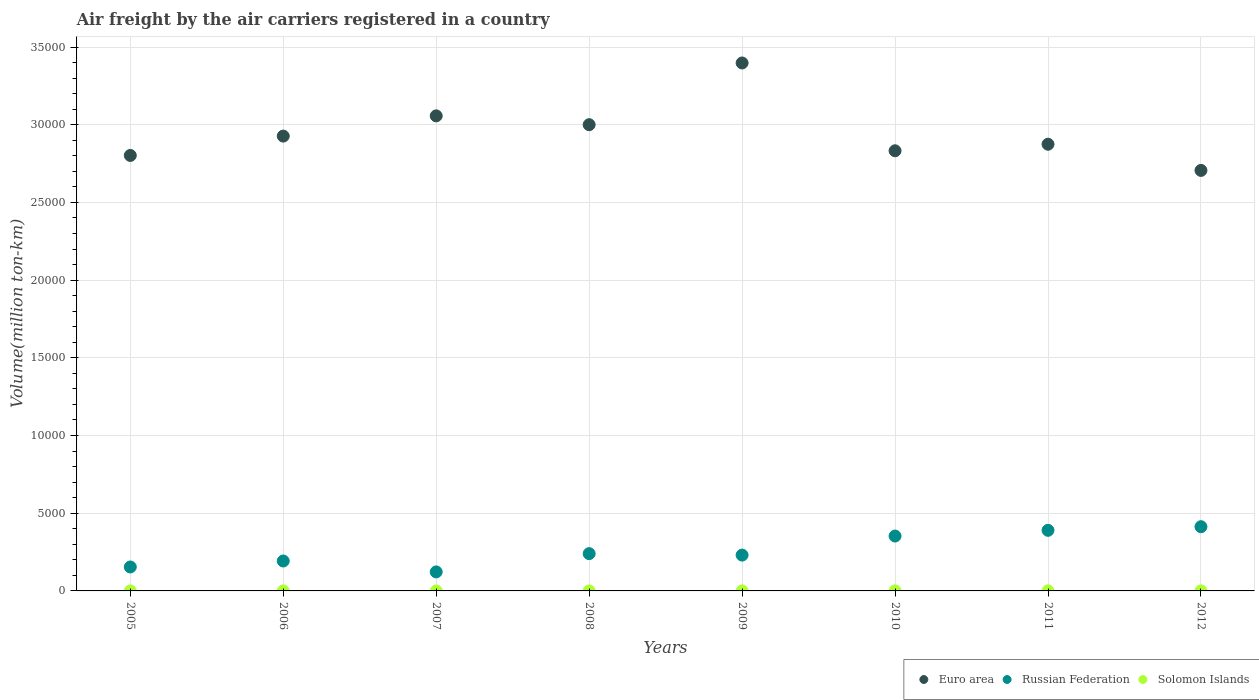Is the number of dotlines equal to the number of legend labels?
Provide a short and direct response. Yes. What is the volume of the air carriers in Solomon Islands in 2006?
Offer a terse response. 0.83. Across all years, what is the maximum volume of the air carriers in Solomon Islands?
Provide a short and direct response. 3.02. Across all years, what is the minimum volume of the air carriers in Solomon Islands?
Give a very brief answer. 0.72. In which year was the volume of the air carriers in Euro area maximum?
Provide a short and direct response. 2009. What is the total volume of the air carriers in Russian Federation in the graph?
Give a very brief answer. 2.10e+04. What is the difference between the volume of the air carriers in Euro area in 2005 and that in 2007?
Your answer should be compact. -2547.47. What is the difference between the volume of the air carriers in Solomon Islands in 2011 and the volume of the air carriers in Russian Federation in 2007?
Offer a terse response. -1221.49. What is the average volume of the air carriers in Euro area per year?
Your answer should be compact. 2.95e+04. In the year 2006, what is the difference between the volume of the air carriers in Russian Federation and volume of the air carriers in Euro area?
Keep it short and to the point. -2.73e+04. In how many years, is the volume of the air carriers in Russian Federation greater than 28000 million ton-km?
Ensure brevity in your answer.  0. What is the ratio of the volume of the air carriers in Russian Federation in 2010 to that in 2011?
Offer a very short reply. 0.91. Is the volume of the air carriers in Euro area in 2007 less than that in 2012?
Keep it short and to the point. No. What is the difference between the highest and the second highest volume of the air carriers in Euro area?
Your answer should be very brief. 3403.68. What is the difference between the highest and the lowest volume of the air carriers in Russian Federation?
Make the answer very short. 2907.83. In how many years, is the volume of the air carriers in Solomon Islands greater than the average volume of the air carriers in Solomon Islands taken over all years?
Provide a short and direct response. 3. Is the sum of the volume of the air carriers in Solomon Islands in 2006 and 2012 greater than the maximum volume of the air carriers in Euro area across all years?
Give a very brief answer. No. How many dotlines are there?
Ensure brevity in your answer.  3. How many years are there in the graph?
Offer a very short reply. 8. What is the difference between two consecutive major ticks on the Y-axis?
Keep it short and to the point. 5000. Are the values on the major ticks of Y-axis written in scientific E-notation?
Keep it short and to the point. No. Does the graph contain any zero values?
Your answer should be very brief. No. Where does the legend appear in the graph?
Make the answer very short. Bottom right. How are the legend labels stacked?
Your response must be concise. Horizontal. What is the title of the graph?
Your answer should be compact. Air freight by the air carriers registered in a country. What is the label or title of the X-axis?
Make the answer very short. Years. What is the label or title of the Y-axis?
Make the answer very short. Volume(million ton-km). What is the Volume(million ton-km) of Euro area in 2005?
Your answer should be very brief. 2.80e+04. What is the Volume(million ton-km) in Russian Federation in 2005?
Your answer should be very brief. 1541.22. What is the Volume(million ton-km) of Solomon Islands in 2005?
Give a very brief answer. 0.8. What is the Volume(million ton-km) in Euro area in 2006?
Provide a short and direct response. 2.93e+04. What is the Volume(million ton-km) of Russian Federation in 2006?
Provide a succinct answer. 1926.3. What is the Volume(million ton-km) in Solomon Islands in 2006?
Give a very brief answer. 0.83. What is the Volume(million ton-km) in Euro area in 2007?
Make the answer very short. 3.06e+04. What is the Volume(million ton-km) of Russian Federation in 2007?
Offer a very short reply. 1224.31. What is the Volume(million ton-km) in Solomon Islands in 2007?
Offer a terse response. 0.88. What is the Volume(million ton-km) of Euro area in 2008?
Offer a very short reply. 3.00e+04. What is the Volume(million ton-km) in Russian Federation in 2008?
Provide a short and direct response. 2399.59. What is the Volume(million ton-km) in Solomon Islands in 2008?
Keep it short and to the point. 0.83. What is the Volume(million ton-km) in Euro area in 2009?
Keep it short and to the point. 3.40e+04. What is the Volume(million ton-km) in Russian Federation in 2009?
Your answer should be very brief. 2305.55. What is the Volume(million ton-km) of Solomon Islands in 2009?
Ensure brevity in your answer.  0.72. What is the Volume(million ton-km) of Euro area in 2010?
Keep it short and to the point. 2.83e+04. What is the Volume(million ton-km) in Russian Federation in 2010?
Make the answer very short. 3531.58. What is the Volume(million ton-km) in Solomon Islands in 2010?
Your answer should be very brief. 2.55. What is the Volume(million ton-km) in Euro area in 2011?
Ensure brevity in your answer.  2.87e+04. What is the Volume(million ton-km) in Russian Federation in 2011?
Give a very brief answer. 3900.12. What is the Volume(million ton-km) in Solomon Islands in 2011?
Give a very brief answer. 2.82. What is the Volume(million ton-km) in Euro area in 2012?
Provide a short and direct response. 2.71e+04. What is the Volume(million ton-km) in Russian Federation in 2012?
Offer a terse response. 4132.14. What is the Volume(million ton-km) in Solomon Islands in 2012?
Keep it short and to the point. 3.02. Across all years, what is the maximum Volume(million ton-km) of Euro area?
Ensure brevity in your answer.  3.40e+04. Across all years, what is the maximum Volume(million ton-km) of Russian Federation?
Offer a terse response. 4132.14. Across all years, what is the maximum Volume(million ton-km) in Solomon Islands?
Offer a terse response. 3.02. Across all years, what is the minimum Volume(million ton-km) of Euro area?
Make the answer very short. 2.71e+04. Across all years, what is the minimum Volume(million ton-km) in Russian Federation?
Offer a very short reply. 1224.31. Across all years, what is the minimum Volume(million ton-km) in Solomon Islands?
Offer a very short reply. 0.72. What is the total Volume(million ton-km) in Euro area in the graph?
Provide a short and direct response. 2.36e+05. What is the total Volume(million ton-km) in Russian Federation in the graph?
Offer a terse response. 2.10e+04. What is the total Volume(million ton-km) in Solomon Islands in the graph?
Offer a very short reply. 12.44. What is the difference between the Volume(million ton-km) in Euro area in 2005 and that in 2006?
Offer a terse response. -1245.56. What is the difference between the Volume(million ton-km) of Russian Federation in 2005 and that in 2006?
Make the answer very short. -385.08. What is the difference between the Volume(million ton-km) in Solomon Islands in 2005 and that in 2006?
Give a very brief answer. -0.03. What is the difference between the Volume(million ton-km) of Euro area in 2005 and that in 2007?
Provide a succinct answer. -2547.47. What is the difference between the Volume(million ton-km) of Russian Federation in 2005 and that in 2007?
Your response must be concise. 316.91. What is the difference between the Volume(million ton-km) in Solomon Islands in 2005 and that in 2007?
Offer a terse response. -0.08. What is the difference between the Volume(million ton-km) in Euro area in 2005 and that in 2008?
Your response must be concise. -1979.42. What is the difference between the Volume(million ton-km) in Russian Federation in 2005 and that in 2008?
Your response must be concise. -858.37. What is the difference between the Volume(million ton-km) of Solomon Islands in 2005 and that in 2008?
Your answer should be compact. -0.03. What is the difference between the Volume(million ton-km) in Euro area in 2005 and that in 2009?
Give a very brief answer. -5951.15. What is the difference between the Volume(million ton-km) of Russian Federation in 2005 and that in 2009?
Provide a succinct answer. -764.33. What is the difference between the Volume(million ton-km) of Solomon Islands in 2005 and that in 2009?
Keep it short and to the point. 0.07. What is the difference between the Volume(million ton-km) of Euro area in 2005 and that in 2010?
Your answer should be compact. -300.19. What is the difference between the Volume(million ton-km) in Russian Federation in 2005 and that in 2010?
Ensure brevity in your answer.  -1990.36. What is the difference between the Volume(million ton-km) in Solomon Islands in 2005 and that in 2010?
Provide a short and direct response. -1.75. What is the difference between the Volume(million ton-km) of Euro area in 2005 and that in 2011?
Provide a short and direct response. -721.69. What is the difference between the Volume(million ton-km) of Russian Federation in 2005 and that in 2011?
Offer a terse response. -2358.9. What is the difference between the Volume(million ton-km) in Solomon Islands in 2005 and that in 2011?
Make the answer very short. -2.02. What is the difference between the Volume(million ton-km) of Euro area in 2005 and that in 2012?
Give a very brief answer. 962.52. What is the difference between the Volume(million ton-km) in Russian Federation in 2005 and that in 2012?
Offer a terse response. -2590.93. What is the difference between the Volume(million ton-km) in Solomon Islands in 2005 and that in 2012?
Your answer should be very brief. -2.23. What is the difference between the Volume(million ton-km) in Euro area in 2006 and that in 2007?
Offer a terse response. -1301.91. What is the difference between the Volume(million ton-km) in Russian Federation in 2006 and that in 2007?
Provide a short and direct response. 701.98. What is the difference between the Volume(million ton-km) of Solomon Islands in 2006 and that in 2007?
Provide a succinct answer. -0.05. What is the difference between the Volume(million ton-km) in Euro area in 2006 and that in 2008?
Offer a terse response. -733.86. What is the difference between the Volume(million ton-km) of Russian Federation in 2006 and that in 2008?
Make the answer very short. -473.3. What is the difference between the Volume(million ton-km) in Solomon Islands in 2006 and that in 2008?
Make the answer very short. -0. What is the difference between the Volume(million ton-km) in Euro area in 2006 and that in 2009?
Give a very brief answer. -4705.59. What is the difference between the Volume(million ton-km) of Russian Federation in 2006 and that in 2009?
Ensure brevity in your answer.  -379.25. What is the difference between the Volume(million ton-km) of Solomon Islands in 2006 and that in 2009?
Make the answer very short. 0.1. What is the difference between the Volume(million ton-km) of Euro area in 2006 and that in 2010?
Ensure brevity in your answer.  945.37. What is the difference between the Volume(million ton-km) in Russian Federation in 2006 and that in 2010?
Offer a very short reply. -1605.29. What is the difference between the Volume(million ton-km) of Solomon Islands in 2006 and that in 2010?
Ensure brevity in your answer.  -1.72. What is the difference between the Volume(million ton-km) of Euro area in 2006 and that in 2011?
Your response must be concise. 523.87. What is the difference between the Volume(million ton-km) of Russian Federation in 2006 and that in 2011?
Provide a short and direct response. -1973.83. What is the difference between the Volume(million ton-km) of Solomon Islands in 2006 and that in 2011?
Provide a short and direct response. -1.99. What is the difference between the Volume(million ton-km) in Euro area in 2006 and that in 2012?
Provide a succinct answer. 2208.08. What is the difference between the Volume(million ton-km) of Russian Federation in 2006 and that in 2012?
Make the answer very short. -2205.85. What is the difference between the Volume(million ton-km) of Solomon Islands in 2006 and that in 2012?
Your answer should be very brief. -2.2. What is the difference between the Volume(million ton-km) of Euro area in 2007 and that in 2008?
Your response must be concise. 568.05. What is the difference between the Volume(million ton-km) in Russian Federation in 2007 and that in 2008?
Provide a succinct answer. -1175.28. What is the difference between the Volume(million ton-km) in Solomon Islands in 2007 and that in 2008?
Your response must be concise. 0.04. What is the difference between the Volume(million ton-km) of Euro area in 2007 and that in 2009?
Provide a succinct answer. -3403.68. What is the difference between the Volume(million ton-km) in Russian Federation in 2007 and that in 2009?
Offer a very short reply. -1081.23. What is the difference between the Volume(million ton-km) in Solomon Islands in 2007 and that in 2009?
Offer a terse response. 0.15. What is the difference between the Volume(million ton-km) in Euro area in 2007 and that in 2010?
Ensure brevity in your answer.  2247.29. What is the difference between the Volume(million ton-km) in Russian Federation in 2007 and that in 2010?
Provide a succinct answer. -2307.27. What is the difference between the Volume(million ton-km) in Solomon Islands in 2007 and that in 2010?
Provide a short and direct response. -1.67. What is the difference between the Volume(million ton-km) of Euro area in 2007 and that in 2011?
Your response must be concise. 1825.79. What is the difference between the Volume(million ton-km) in Russian Federation in 2007 and that in 2011?
Provide a succinct answer. -2675.81. What is the difference between the Volume(million ton-km) of Solomon Islands in 2007 and that in 2011?
Provide a succinct answer. -1.94. What is the difference between the Volume(million ton-km) of Euro area in 2007 and that in 2012?
Provide a short and direct response. 3509.99. What is the difference between the Volume(million ton-km) of Russian Federation in 2007 and that in 2012?
Provide a succinct answer. -2907.83. What is the difference between the Volume(million ton-km) of Solomon Islands in 2007 and that in 2012?
Ensure brevity in your answer.  -2.15. What is the difference between the Volume(million ton-km) in Euro area in 2008 and that in 2009?
Ensure brevity in your answer.  -3971.73. What is the difference between the Volume(million ton-km) of Russian Federation in 2008 and that in 2009?
Your response must be concise. 94.05. What is the difference between the Volume(million ton-km) of Solomon Islands in 2008 and that in 2009?
Your answer should be very brief. 0.11. What is the difference between the Volume(million ton-km) in Euro area in 2008 and that in 2010?
Provide a succinct answer. 1679.23. What is the difference between the Volume(million ton-km) of Russian Federation in 2008 and that in 2010?
Give a very brief answer. -1131.99. What is the difference between the Volume(million ton-km) of Solomon Islands in 2008 and that in 2010?
Your response must be concise. -1.72. What is the difference between the Volume(million ton-km) in Euro area in 2008 and that in 2011?
Your answer should be compact. 1257.73. What is the difference between the Volume(million ton-km) in Russian Federation in 2008 and that in 2011?
Your answer should be very brief. -1500.53. What is the difference between the Volume(million ton-km) in Solomon Islands in 2008 and that in 2011?
Your answer should be very brief. -1.99. What is the difference between the Volume(million ton-km) of Euro area in 2008 and that in 2012?
Offer a very short reply. 2941.94. What is the difference between the Volume(million ton-km) of Russian Federation in 2008 and that in 2012?
Offer a very short reply. -1732.55. What is the difference between the Volume(million ton-km) in Solomon Islands in 2008 and that in 2012?
Offer a terse response. -2.19. What is the difference between the Volume(million ton-km) of Euro area in 2009 and that in 2010?
Make the answer very short. 5650.96. What is the difference between the Volume(million ton-km) of Russian Federation in 2009 and that in 2010?
Your answer should be very brief. -1226.04. What is the difference between the Volume(million ton-km) in Solomon Islands in 2009 and that in 2010?
Your response must be concise. -1.82. What is the difference between the Volume(million ton-km) in Euro area in 2009 and that in 2011?
Offer a very short reply. 5229.46. What is the difference between the Volume(million ton-km) of Russian Federation in 2009 and that in 2011?
Your answer should be very brief. -1594.57. What is the difference between the Volume(million ton-km) in Solomon Islands in 2009 and that in 2011?
Your answer should be compact. -2.1. What is the difference between the Volume(million ton-km) of Euro area in 2009 and that in 2012?
Make the answer very short. 6913.67. What is the difference between the Volume(million ton-km) in Russian Federation in 2009 and that in 2012?
Your response must be concise. -1826.6. What is the difference between the Volume(million ton-km) in Solomon Islands in 2009 and that in 2012?
Keep it short and to the point. -2.3. What is the difference between the Volume(million ton-km) in Euro area in 2010 and that in 2011?
Offer a very short reply. -421.5. What is the difference between the Volume(million ton-km) in Russian Federation in 2010 and that in 2011?
Your response must be concise. -368.54. What is the difference between the Volume(million ton-km) in Solomon Islands in 2010 and that in 2011?
Offer a very short reply. -0.27. What is the difference between the Volume(million ton-km) in Euro area in 2010 and that in 2012?
Offer a very short reply. 1262.71. What is the difference between the Volume(million ton-km) of Russian Federation in 2010 and that in 2012?
Provide a short and direct response. -600.56. What is the difference between the Volume(million ton-km) in Solomon Islands in 2010 and that in 2012?
Offer a very short reply. -0.48. What is the difference between the Volume(million ton-km) in Euro area in 2011 and that in 2012?
Provide a succinct answer. 1684.21. What is the difference between the Volume(million ton-km) in Russian Federation in 2011 and that in 2012?
Provide a succinct answer. -232.02. What is the difference between the Volume(million ton-km) in Solomon Islands in 2011 and that in 2012?
Offer a very short reply. -0.21. What is the difference between the Volume(million ton-km) of Euro area in 2005 and the Volume(million ton-km) of Russian Federation in 2006?
Provide a short and direct response. 2.61e+04. What is the difference between the Volume(million ton-km) in Euro area in 2005 and the Volume(million ton-km) in Solomon Islands in 2006?
Make the answer very short. 2.80e+04. What is the difference between the Volume(million ton-km) of Russian Federation in 2005 and the Volume(million ton-km) of Solomon Islands in 2006?
Your answer should be very brief. 1540.39. What is the difference between the Volume(million ton-km) in Euro area in 2005 and the Volume(million ton-km) in Russian Federation in 2007?
Provide a short and direct response. 2.68e+04. What is the difference between the Volume(million ton-km) in Euro area in 2005 and the Volume(million ton-km) in Solomon Islands in 2007?
Provide a short and direct response. 2.80e+04. What is the difference between the Volume(million ton-km) in Russian Federation in 2005 and the Volume(million ton-km) in Solomon Islands in 2007?
Give a very brief answer. 1540.34. What is the difference between the Volume(million ton-km) of Euro area in 2005 and the Volume(million ton-km) of Russian Federation in 2008?
Ensure brevity in your answer.  2.56e+04. What is the difference between the Volume(million ton-km) in Euro area in 2005 and the Volume(million ton-km) in Solomon Islands in 2008?
Ensure brevity in your answer.  2.80e+04. What is the difference between the Volume(million ton-km) in Russian Federation in 2005 and the Volume(million ton-km) in Solomon Islands in 2008?
Give a very brief answer. 1540.39. What is the difference between the Volume(million ton-km) of Euro area in 2005 and the Volume(million ton-km) of Russian Federation in 2009?
Your answer should be very brief. 2.57e+04. What is the difference between the Volume(million ton-km) of Euro area in 2005 and the Volume(million ton-km) of Solomon Islands in 2009?
Your answer should be compact. 2.80e+04. What is the difference between the Volume(million ton-km) in Russian Federation in 2005 and the Volume(million ton-km) in Solomon Islands in 2009?
Offer a terse response. 1540.5. What is the difference between the Volume(million ton-km) of Euro area in 2005 and the Volume(million ton-km) of Russian Federation in 2010?
Your answer should be very brief. 2.45e+04. What is the difference between the Volume(million ton-km) in Euro area in 2005 and the Volume(million ton-km) in Solomon Islands in 2010?
Ensure brevity in your answer.  2.80e+04. What is the difference between the Volume(million ton-km) in Russian Federation in 2005 and the Volume(million ton-km) in Solomon Islands in 2010?
Your response must be concise. 1538.67. What is the difference between the Volume(million ton-km) in Euro area in 2005 and the Volume(million ton-km) in Russian Federation in 2011?
Offer a very short reply. 2.41e+04. What is the difference between the Volume(million ton-km) of Euro area in 2005 and the Volume(million ton-km) of Solomon Islands in 2011?
Give a very brief answer. 2.80e+04. What is the difference between the Volume(million ton-km) of Russian Federation in 2005 and the Volume(million ton-km) of Solomon Islands in 2011?
Provide a succinct answer. 1538.4. What is the difference between the Volume(million ton-km) of Euro area in 2005 and the Volume(million ton-km) of Russian Federation in 2012?
Give a very brief answer. 2.39e+04. What is the difference between the Volume(million ton-km) in Euro area in 2005 and the Volume(million ton-km) in Solomon Islands in 2012?
Provide a succinct answer. 2.80e+04. What is the difference between the Volume(million ton-km) in Russian Federation in 2005 and the Volume(million ton-km) in Solomon Islands in 2012?
Offer a terse response. 1538.19. What is the difference between the Volume(million ton-km) in Euro area in 2006 and the Volume(million ton-km) in Russian Federation in 2007?
Give a very brief answer. 2.80e+04. What is the difference between the Volume(million ton-km) of Euro area in 2006 and the Volume(million ton-km) of Solomon Islands in 2007?
Your answer should be compact. 2.93e+04. What is the difference between the Volume(million ton-km) in Russian Federation in 2006 and the Volume(million ton-km) in Solomon Islands in 2007?
Your answer should be very brief. 1925.42. What is the difference between the Volume(million ton-km) of Euro area in 2006 and the Volume(million ton-km) of Russian Federation in 2008?
Your answer should be compact. 2.69e+04. What is the difference between the Volume(million ton-km) in Euro area in 2006 and the Volume(million ton-km) in Solomon Islands in 2008?
Give a very brief answer. 2.93e+04. What is the difference between the Volume(million ton-km) in Russian Federation in 2006 and the Volume(million ton-km) in Solomon Islands in 2008?
Ensure brevity in your answer.  1925.46. What is the difference between the Volume(million ton-km) in Euro area in 2006 and the Volume(million ton-km) in Russian Federation in 2009?
Give a very brief answer. 2.70e+04. What is the difference between the Volume(million ton-km) in Euro area in 2006 and the Volume(million ton-km) in Solomon Islands in 2009?
Offer a very short reply. 2.93e+04. What is the difference between the Volume(million ton-km) of Russian Federation in 2006 and the Volume(million ton-km) of Solomon Islands in 2009?
Offer a terse response. 1925.57. What is the difference between the Volume(million ton-km) in Euro area in 2006 and the Volume(million ton-km) in Russian Federation in 2010?
Your answer should be very brief. 2.57e+04. What is the difference between the Volume(million ton-km) of Euro area in 2006 and the Volume(million ton-km) of Solomon Islands in 2010?
Your answer should be very brief. 2.93e+04. What is the difference between the Volume(million ton-km) in Russian Federation in 2006 and the Volume(million ton-km) in Solomon Islands in 2010?
Give a very brief answer. 1923.75. What is the difference between the Volume(million ton-km) in Euro area in 2006 and the Volume(million ton-km) in Russian Federation in 2011?
Offer a terse response. 2.54e+04. What is the difference between the Volume(million ton-km) in Euro area in 2006 and the Volume(million ton-km) in Solomon Islands in 2011?
Your response must be concise. 2.93e+04. What is the difference between the Volume(million ton-km) of Russian Federation in 2006 and the Volume(million ton-km) of Solomon Islands in 2011?
Offer a very short reply. 1923.48. What is the difference between the Volume(million ton-km) of Euro area in 2006 and the Volume(million ton-km) of Russian Federation in 2012?
Your response must be concise. 2.51e+04. What is the difference between the Volume(million ton-km) in Euro area in 2006 and the Volume(million ton-km) in Solomon Islands in 2012?
Make the answer very short. 2.93e+04. What is the difference between the Volume(million ton-km) of Russian Federation in 2006 and the Volume(million ton-km) of Solomon Islands in 2012?
Make the answer very short. 1923.27. What is the difference between the Volume(million ton-km) in Euro area in 2007 and the Volume(million ton-km) in Russian Federation in 2008?
Offer a very short reply. 2.82e+04. What is the difference between the Volume(million ton-km) of Euro area in 2007 and the Volume(million ton-km) of Solomon Islands in 2008?
Ensure brevity in your answer.  3.06e+04. What is the difference between the Volume(million ton-km) in Russian Federation in 2007 and the Volume(million ton-km) in Solomon Islands in 2008?
Keep it short and to the point. 1223.48. What is the difference between the Volume(million ton-km) of Euro area in 2007 and the Volume(million ton-km) of Russian Federation in 2009?
Provide a succinct answer. 2.83e+04. What is the difference between the Volume(million ton-km) in Euro area in 2007 and the Volume(million ton-km) in Solomon Islands in 2009?
Your answer should be compact. 3.06e+04. What is the difference between the Volume(million ton-km) of Russian Federation in 2007 and the Volume(million ton-km) of Solomon Islands in 2009?
Offer a very short reply. 1223.59. What is the difference between the Volume(million ton-km) of Euro area in 2007 and the Volume(million ton-km) of Russian Federation in 2010?
Ensure brevity in your answer.  2.70e+04. What is the difference between the Volume(million ton-km) of Euro area in 2007 and the Volume(million ton-km) of Solomon Islands in 2010?
Provide a short and direct response. 3.06e+04. What is the difference between the Volume(million ton-km) in Russian Federation in 2007 and the Volume(million ton-km) in Solomon Islands in 2010?
Offer a very short reply. 1221.77. What is the difference between the Volume(million ton-km) in Euro area in 2007 and the Volume(million ton-km) in Russian Federation in 2011?
Offer a very short reply. 2.67e+04. What is the difference between the Volume(million ton-km) in Euro area in 2007 and the Volume(million ton-km) in Solomon Islands in 2011?
Offer a terse response. 3.06e+04. What is the difference between the Volume(million ton-km) of Russian Federation in 2007 and the Volume(million ton-km) of Solomon Islands in 2011?
Ensure brevity in your answer.  1221.49. What is the difference between the Volume(million ton-km) in Euro area in 2007 and the Volume(million ton-km) in Russian Federation in 2012?
Provide a succinct answer. 2.64e+04. What is the difference between the Volume(million ton-km) in Euro area in 2007 and the Volume(million ton-km) in Solomon Islands in 2012?
Ensure brevity in your answer.  3.06e+04. What is the difference between the Volume(million ton-km) of Russian Federation in 2007 and the Volume(million ton-km) of Solomon Islands in 2012?
Provide a succinct answer. 1221.29. What is the difference between the Volume(million ton-km) in Euro area in 2008 and the Volume(million ton-km) in Russian Federation in 2009?
Keep it short and to the point. 2.77e+04. What is the difference between the Volume(million ton-km) of Euro area in 2008 and the Volume(million ton-km) of Solomon Islands in 2009?
Provide a succinct answer. 3.00e+04. What is the difference between the Volume(million ton-km) in Russian Federation in 2008 and the Volume(million ton-km) in Solomon Islands in 2009?
Offer a terse response. 2398.87. What is the difference between the Volume(million ton-km) in Euro area in 2008 and the Volume(million ton-km) in Russian Federation in 2010?
Offer a terse response. 2.65e+04. What is the difference between the Volume(million ton-km) of Euro area in 2008 and the Volume(million ton-km) of Solomon Islands in 2010?
Your response must be concise. 3.00e+04. What is the difference between the Volume(million ton-km) of Russian Federation in 2008 and the Volume(million ton-km) of Solomon Islands in 2010?
Your answer should be compact. 2397.05. What is the difference between the Volume(million ton-km) of Euro area in 2008 and the Volume(million ton-km) of Russian Federation in 2011?
Ensure brevity in your answer.  2.61e+04. What is the difference between the Volume(million ton-km) of Euro area in 2008 and the Volume(million ton-km) of Solomon Islands in 2011?
Offer a terse response. 3.00e+04. What is the difference between the Volume(million ton-km) of Russian Federation in 2008 and the Volume(million ton-km) of Solomon Islands in 2011?
Provide a short and direct response. 2396.77. What is the difference between the Volume(million ton-km) of Euro area in 2008 and the Volume(million ton-km) of Russian Federation in 2012?
Your answer should be compact. 2.59e+04. What is the difference between the Volume(million ton-km) of Euro area in 2008 and the Volume(million ton-km) of Solomon Islands in 2012?
Ensure brevity in your answer.  3.00e+04. What is the difference between the Volume(million ton-km) of Russian Federation in 2008 and the Volume(million ton-km) of Solomon Islands in 2012?
Your answer should be compact. 2396.57. What is the difference between the Volume(million ton-km) in Euro area in 2009 and the Volume(million ton-km) in Russian Federation in 2010?
Provide a short and direct response. 3.04e+04. What is the difference between the Volume(million ton-km) of Euro area in 2009 and the Volume(million ton-km) of Solomon Islands in 2010?
Keep it short and to the point. 3.40e+04. What is the difference between the Volume(million ton-km) in Russian Federation in 2009 and the Volume(million ton-km) in Solomon Islands in 2010?
Your answer should be compact. 2303. What is the difference between the Volume(million ton-km) in Euro area in 2009 and the Volume(million ton-km) in Russian Federation in 2011?
Ensure brevity in your answer.  3.01e+04. What is the difference between the Volume(million ton-km) in Euro area in 2009 and the Volume(million ton-km) in Solomon Islands in 2011?
Your response must be concise. 3.40e+04. What is the difference between the Volume(million ton-km) of Russian Federation in 2009 and the Volume(million ton-km) of Solomon Islands in 2011?
Provide a short and direct response. 2302.73. What is the difference between the Volume(million ton-km) in Euro area in 2009 and the Volume(million ton-km) in Russian Federation in 2012?
Offer a very short reply. 2.98e+04. What is the difference between the Volume(million ton-km) in Euro area in 2009 and the Volume(million ton-km) in Solomon Islands in 2012?
Your response must be concise. 3.40e+04. What is the difference between the Volume(million ton-km) of Russian Federation in 2009 and the Volume(million ton-km) of Solomon Islands in 2012?
Offer a very short reply. 2302.52. What is the difference between the Volume(million ton-km) of Euro area in 2010 and the Volume(million ton-km) of Russian Federation in 2011?
Your answer should be compact. 2.44e+04. What is the difference between the Volume(million ton-km) in Euro area in 2010 and the Volume(million ton-km) in Solomon Islands in 2011?
Keep it short and to the point. 2.83e+04. What is the difference between the Volume(million ton-km) of Russian Federation in 2010 and the Volume(million ton-km) of Solomon Islands in 2011?
Offer a very short reply. 3528.76. What is the difference between the Volume(million ton-km) of Euro area in 2010 and the Volume(million ton-km) of Russian Federation in 2012?
Ensure brevity in your answer.  2.42e+04. What is the difference between the Volume(million ton-km) of Euro area in 2010 and the Volume(million ton-km) of Solomon Islands in 2012?
Offer a terse response. 2.83e+04. What is the difference between the Volume(million ton-km) of Russian Federation in 2010 and the Volume(million ton-km) of Solomon Islands in 2012?
Your answer should be compact. 3528.56. What is the difference between the Volume(million ton-km) in Euro area in 2011 and the Volume(million ton-km) in Russian Federation in 2012?
Your answer should be very brief. 2.46e+04. What is the difference between the Volume(million ton-km) in Euro area in 2011 and the Volume(million ton-km) in Solomon Islands in 2012?
Provide a succinct answer. 2.87e+04. What is the difference between the Volume(million ton-km) of Russian Federation in 2011 and the Volume(million ton-km) of Solomon Islands in 2012?
Your response must be concise. 3897.1. What is the average Volume(million ton-km) in Euro area per year?
Offer a terse response. 2.95e+04. What is the average Volume(million ton-km) of Russian Federation per year?
Your answer should be very brief. 2620.1. What is the average Volume(million ton-km) of Solomon Islands per year?
Provide a succinct answer. 1.56. In the year 2005, what is the difference between the Volume(million ton-km) of Euro area and Volume(million ton-km) of Russian Federation?
Your response must be concise. 2.65e+04. In the year 2005, what is the difference between the Volume(million ton-km) in Euro area and Volume(million ton-km) in Solomon Islands?
Offer a very short reply. 2.80e+04. In the year 2005, what is the difference between the Volume(million ton-km) in Russian Federation and Volume(million ton-km) in Solomon Islands?
Your answer should be very brief. 1540.42. In the year 2006, what is the difference between the Volume(million ton-km) of Euro area and Volume(million ton-km) of Russian Federation?
Ensure brevity in your answer.  2.73e+04. In the year 2006, what is the difference between the Volume(million ton-km) of Euro area and Volume(million ton-km) of Solomon Islands?
Make the answer very short. 2.93e+04. In the year 2006, what is the difference between the Volume(million ton-km) of Russian Federation and Volume(million ton-km) of Solomon Islands?
Your response must be concise. 1925.47. In the year 2007, what is the difference between the Volume(million ton-km) of Euro area and Volume(million ton-km) of Russian Federation?
Your answer should be very brief. 2.93e+04. In the year 2007, what is the difference between the Volume(million ton-km) of Euro area and Volume(million ton-km) of Solomon Islands?
Provide a succinct answer. 3.06e+04. In the year 2007, what is the difference between the Volume(million ton-km) in Russian Federation and Volume(million ton-km) in Solomon Islands?
Keep it short and to the point. 1223.44. In the year 2008, what is the difference between the Volume(million ton-km) of Euro area and Volume(million ton-km) of Russian Federation?
Give a very brief answer. 2.76e+04. In the year 2008, what is the difference between the Volume(million ton-km) in Euro area and Volume(million ton-km) in Solomon Islands?
Provide a succinct answer. 3.00e+04. In the year 2008, what is the difference between the Volume(million ton-km) of Russian Federation and Volume(million ton-km) of Solomon Islands?
Offer a very short reply. 2398.76. In the year 2009, what is the difference between the Volume(million ton-km) of Euro area and Volume(million ton-km) of Russian Federation?
Provide a succinct answer. 3.17e+04. In the year 2009, what is the difference between the Volume(million ton-km) in Euro area and Volume(million ton-km) in Solomon Islands?
Your response must be concise. 3.40e+04. In the year 2009, what is the difference between the Volume(million ton-km) of Russian Federation and Volume(million ton-km) of Solomon Islands?
Provide a short and direct response. 2304.82. In the year 2010, what is the difference between the Volume(million ton-km) of Euro area and Volume(million ton-km) of Russian Federation?
Provide a short and direct response. 2.48e+04. In the year 2010, what is the difference between the Volume(million ton-km) in Euro area and Volume(million ton-km) in Solomon Islands?
Your answer should be compact. 2.83e+04. In the year 2010, what is the difference between the Volume(million ton-km) of Russian Federation and Volume(million ton-km) of Solomon Islands?
Your response must be concise. 3529.04. In the year 2011, what is the difference between the Volume(million ton-km) in Euro area and Volume(million ton-km) in Russian Federation?
Your response must be concise. 2.48e+04. In the year 2011, what is the difference between the Volume(million ton-km) in Euro area and Volume(million ton-km) in Solomon Islands?
Your response must be concise. 2.87e+04. In the year 2011, what is the difference between the Volume(million ton-km) of Russian Federation and Volume(million ton-km) of Solomon Islands?
Offer a very short reply. 3897.3. In the year 2012, what is the difference between the Volume(million ton-km) of Euro area and Volume(million ton-km) of Russian Federation?
Offer a very short reply. 2.29e+04. In the year 2012, what is the difference between the Volume(million ton-km) in Euro area and Volume(million ton-km) in Solomon Islands?
Provide a short and direct response. 2.71e+04. In the year 2012, what is the difference between the Volume(million ton-km) in Russian Federation and Volume(million ton-km) in Solomon Islands?
Provide a short and direct response. 4129.12. What is the ratio of the Volume(million ton-km) of Euro area in 2005 to that in 2006?
Give a very brief answer. 0.96. What is the ratio of the Volume(million ton-km) of Russian Federation in 2005 to that in 2006?
Offer a very short reply. 0.8. What is the ratio of the Volume(million ton-km) of Solomon Islands in 2005 to that in 2006?
Give a very brief answer. 0.96. What is the ratio of the Volume(million ton-km) in Russian Federation in 2005 to that in 2007?
Keep it short and to the point. 1.26. What is the ratio of the Volume(million ton-km) of Solomon Islands in 2005 to that in 2007?
Offer a very short reply. 0.91. What is the ratio of the Volume(million ton-km) of Euro area in 2005 to that in 2008?
Offer a very short reply. 0.93. What is the ratio of the Volume(million ton-km) in Russian Federation in 2005 to that in 2008?
Give a very brief answer. 0.64. What is the ratio of the Volume(million ton-km) in Solomon Islands in 2005 to that in 2008?
Your answer should be very brief. 0.96. What is the ratio of the Volume(million ton-km) of Euro area in 2005 to that in 2009?
Give a very brief answer. 0.82. What is the ratio of the Volume(million ton-km) in Russian Federation in 2005 to that in 2009?
Offer a terse response. 0.67. What is the ratio of the Volume(million ton-km) in Solomon Islands in 2005 to that in 2009?
Provide a succinct answer. 1.1. What is the ratio of the Volume(million ton-km) in Russian Federation in 2005 to that in 2010?
Provide a succinct answer. 0.44. What is the ratio of the Volume(million ton-km) in Solomon Islands in 2005 to that in 2010?
Give a very brief answer. 0.31. What is the ratio of the Volume(million ton-km) in Euro area in 2005 to that in 2011?
Your answer should be compact. 0.97. What is the ratio of the Volume(million ton-km) of Russian Federation in 2005 to that in 2011?
Your answer should be compact. 0.4. What is the ratio of the Volume(million ton-km) in Solomon Islands in 2005 to that in 2011?
Offer a very short reply. 0.28. What is the ratio of the Volume(million ton-km) of Euro area in 2005 to that in 2012?
Ensure brevity in your answer.  1.04. What is the ratio of the Volume(million ton-km) of Russian Federation in 2005 to that in 2012?
Provide a short and direct response. 0.37. What is the ratio of the Volume(million ton-km) in Solomon Islands in 2005 to that in 2012?
Provide a short and direct response. 0.26. What is the ratio of the Volume(million ton-km) in Euro area in 2006 to that in 2007?
Offer a terse response. 0.96. What is the ratio of the Volume(million ton-km) in Russian Federation in 2006 to that in 2007?
Make the answer very short. 1.57. What is the ratio of the Volume(million ton-km) in Solomon Islands in 2006 to that in 2007?
Your answer should be compact. 0.95. What is the ratio of the Volume(million ton-km) in Euro area in 2006 to that in 2008?
Your answer should be very brief. 0.98. What is the ratio of the Volume(million ton-km) of Russian Federation in 2006 to that in 2008?
Keep it short and to the point. 0.8. What is the ratio of the Volume(million ton-km) of Euro area in 2006 to that in 2009?
Offer a terse response. 0.86. What is the ratio of the Volume(million ton-km) in Russian Federation in 2006 to that in 2009?
Provide a short and direct response. 0.84. What is the ratio of the Volume(million ton-km) of Solomon Islands in 2006 to that in 2009?
Provide a succinct answer. 1.15. What is the ratio of the Volume(million ton-km) of Euro area in 2006 to that in 2010?
Your response must be concise. 1.03. What is the ratio of the Volume(million ton-km) of Russian Federation in 2006 to that in 2010?
Ensure brevity in your answer.  0.55. What is the ratio of the Volume(million ton-km) in Solomon Islands in 2006 to that in 2010?
Your response must be concise. 0.33. What is the ratio of the Volume(million ton-km) of Euro area in 2006 to that in 2011?
Your answer should be very brief. 1.02. What is the ratio of the Volume(million ton-km) of Russian Federation in 2006 to that in 2011?
Your answer should be compact. 0.49. What is the ratio of the Volume(million ton-km) in Solomon Islands in 2006 to that in 2011?
Offer a terse response. 0.29. What is the ratio of the Volume(million ton-km) in Euro area in 2006 to that in 2012?
Keep it short and to the point. 1.08. What is the ratio of the Volume(million ton-km) in Russian Federation in 2006 to that in 2012?
Offer a terse response. 0.47. What is the ratio of the Volume(million ton-km) of Solomon Islands in 2006 to that in 2012?
Keep it short and to the point. 0.27. What is the ratio of the Volume(million ton-km) of Euro area in 2007 to that in 2008?
Provide a short and direct response. 1.02. What is the ratio of the Volume(million ton-km) of Russian Federation in 2007 to that in 2008?
Your answer should be compact. 0.51. What is the ratio of the Volume(million ton-km) of Solomon Islands in 2007 to that in 2008?
Your answer should be compact. 1.05. What is the ratio of the Volume(million ton-km) of Euro area in 2007 to that in 2009?
Offer a terse response. 0.9. What is the ratio of the Volume(million ton-km) in Russian Federation in 2007 to that in 2009?
Keep it short and to the point. 0.53. What is the ratio of the Volume(million ton-km) in Solomon Islands in 2007 to that in 2009?
Provide a succinct answer. 1.21. What is the ratio of the Volume(million ton-km) of Euro area in 2007 to that in 2010?
Your answer should be very brief. 1.08. What is the ratio of the Volume(million ton-km) in Russian Federation in 2007 to that in 2010?
Give a very brief answer. 0.35. What is the ratio of the Volume(million ton-km) of Solomon Islands in 2007 to that in 2010?
Keep it short and to the point. 0.34. What is the ratio of the Volume(million ton-km) in Euro area in 2007 to that in 2011?
Provide a succinct answer. 1.06. What is the ratio of the Volume(million ton-km) of Russian Federation in 2007 to that in 2011?
Provide a short and direct response. 0.31. What is the ratio of the Volume(million ton-km) of Solomon Islands in 2007 to that in 2011?
Provide a succinct answer. 0.31. What is the ratio of the Volume(million ton-km) in Euro area in 2007 to that in 2012?
Keep it short and to the point. 1.13. What is the ratio of the Volume(million ton-km) of Russian Federation in 2007 to that in 2012?
Keep it short and to the point. 0.3. What is the ratio of the Volume(million ton-km) in Solomon Islands in 2007 to that in 2012?
Offer a very short reply. 0.29. What is the ratio of the Volume(million ton-km) in Euro area in 2008 to that in 2009?
Your answer should be very brief. 0.88. What is the ratio of the Volume(million ton-km) of Russian Federation in 2008 to that in 2009?
Your response must be concise. 1.04. What is the ratio of the Volume(million ton-km) of Solomon Islands in 2008 to that in 2009?
Provide a succinct answer. 1.15. What is the ratio of the Volume(million ton-km) in Euro area in 2008 to that in 2010?
Make the answer very short. 1.06. What is the ratio of the Volume(million ton-km) of Russian Federation in 2008 to that in 2010?
Ensure brevity in your answer.  0.68. What is the ratio of the Volume(million ton-km) of Solomon Islands in 2008 to that in 2010?
Your answer should be very brief. 0.33. What is the ratio of the Volume(million ton-km) of Euro area in 2008 to that in 2011?
Make the answer very short. 1.04. What is the ratio of the Volume(million ton-km) of Russian Federation in 2008 to that in 2011?
Ensure brevity in your answer.  0.62. What is the ratio of the Volume(million ton-km) of Solomon Islands in 2008 to that in 2011?
Ensure brevity in your answer.  0.29. What is the ratio of the Volume(million ton-km) of Euro area in 2008 to that in 2012?
Keep it short and to the point. 1.11. What is the ratio of the Volume(million ton-km) in Russian Federation in 2008 to that in 2012?
Provide a short and direct response. 0.58. What is the ratio of the Volume(million ton-km) in Solomon Islands in 2008 to that in 2012?
Your response must be concise. 0.27. What is the ratio of the Volume(million ton-km) in Euro area in 2009 to that in 2010?
Provide a succinct answer. 1.2. What is the ratio of the Volume(million ton-km) in Russian Federation in 2009 to that in 2010?
Provide a short and direct response. 0.65. What is the ratio of the Volume(million ton-km) of Solomon Islands in 2009 to that in 2010?
Ensure brevity in your answer.  0.28. What is the ratio of the Volume(million ton-km) in Euro area in 2009 to that in 2011?
Your answer should be very brief. 1.18. What is the ratio of the Volume(million ton-km) of Russian Federation in 2009 to that in 2011?
Make the answer very short. 0.59. What is the ratio of the Volume(million ton-km) of Solomon Islands in 2009 to that in 2011?
Give a very brief answer. 0.26. What is the ratio of the Volume(million ton-km) in Euro area in 2009 to that in 2012?
Offer a very short reply. 1.26. What is the ratio of the Volume(million ton-km) in Russian Federation in 2009 to that in 2012?
Provide a succinct answer. 0.56. What is the ratio of the Volume(million ton-km) in Solomon Islands in 2009 to that in 2012?
Keep it short and to the point. 0.24. What is the ratio of the Volume(million ton-km) of Euro area in 2010 to that in 2011?
Ensure brevity in your answer.  0.99. What is the ratio of the Volume(million ton-km) in Russian Federation in 2010 to that in 2011?
Offer a terse response. 0.91. What is the ratio of the Volume(million ton-km) of Solomon Islands in 2010 to that in 2011?
Make the answer very short. 0.9. What is the ratio of the Volume(million ton-km) of Euro area in 2010 to that in 2012?
Make the answer very short. 1.05. What is the ratio of the Volume(million ton-km) of Russian Federation in 2010 to that in 2012?
Offer a very short reply. 0.85. What is the ratio of the Volume(million ton-km) of Solomon Islands in 2010 to that in 2012?
Give a very brief answer. 0.84. What is the ratio of the Volume(million ton-km) in Euro area in 2011 to that in 2012?
Ensure brevity in your answer.  1.06. What is the ratio of the Volume(million ton-km) in Russian Federation in 2011 to that in 2012?
Offer a terse response. 0.94. What is the ratio of the Volume(million ton-km) in Solomon Islands in 2011 to that in 2012?
Make the answer very short. 0.93. What is the difference between the highest and the second highest Volume(million ton-km) of Euro area?
Offer a terse response. 3403.68. What is the difference between the highest and the second highest Volume(million ton-km) in Russian Federation?
Offer a very short reply. 232.02. What is the difference between the highest and the second highest Volume(million ton-km) in Solomon Islands?
Your answer should be compact. 0.21. What is the difference between the highest and the lowest Volume(million ton-km) of Euro area?
Make the answer very short. 6913.67. What is the difference between the highest and the lowest Volume(million ton-km) in Russian Federation?
Your answer should be very brief. 2907.83. What is the difference between the highest and the lowest Volume(million ton-km) in Solomon Islands?
Make the answer very short. 2.3. 